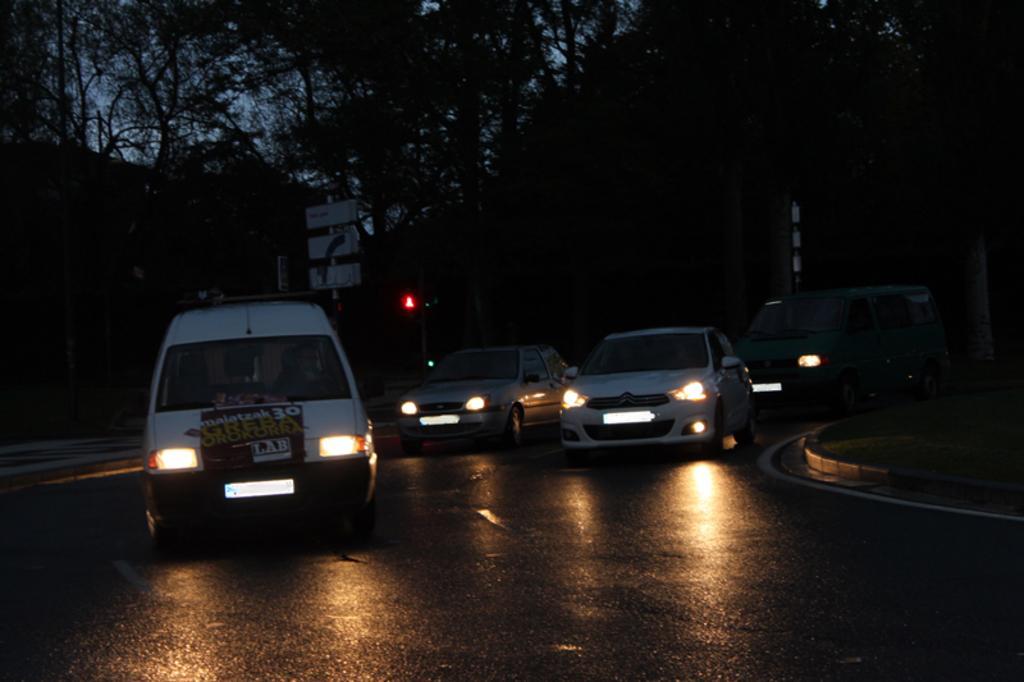In one or two sentences, can you explain what this image depicts? In this image I can see few vehicles are moving on the road. At the top there are trees. 